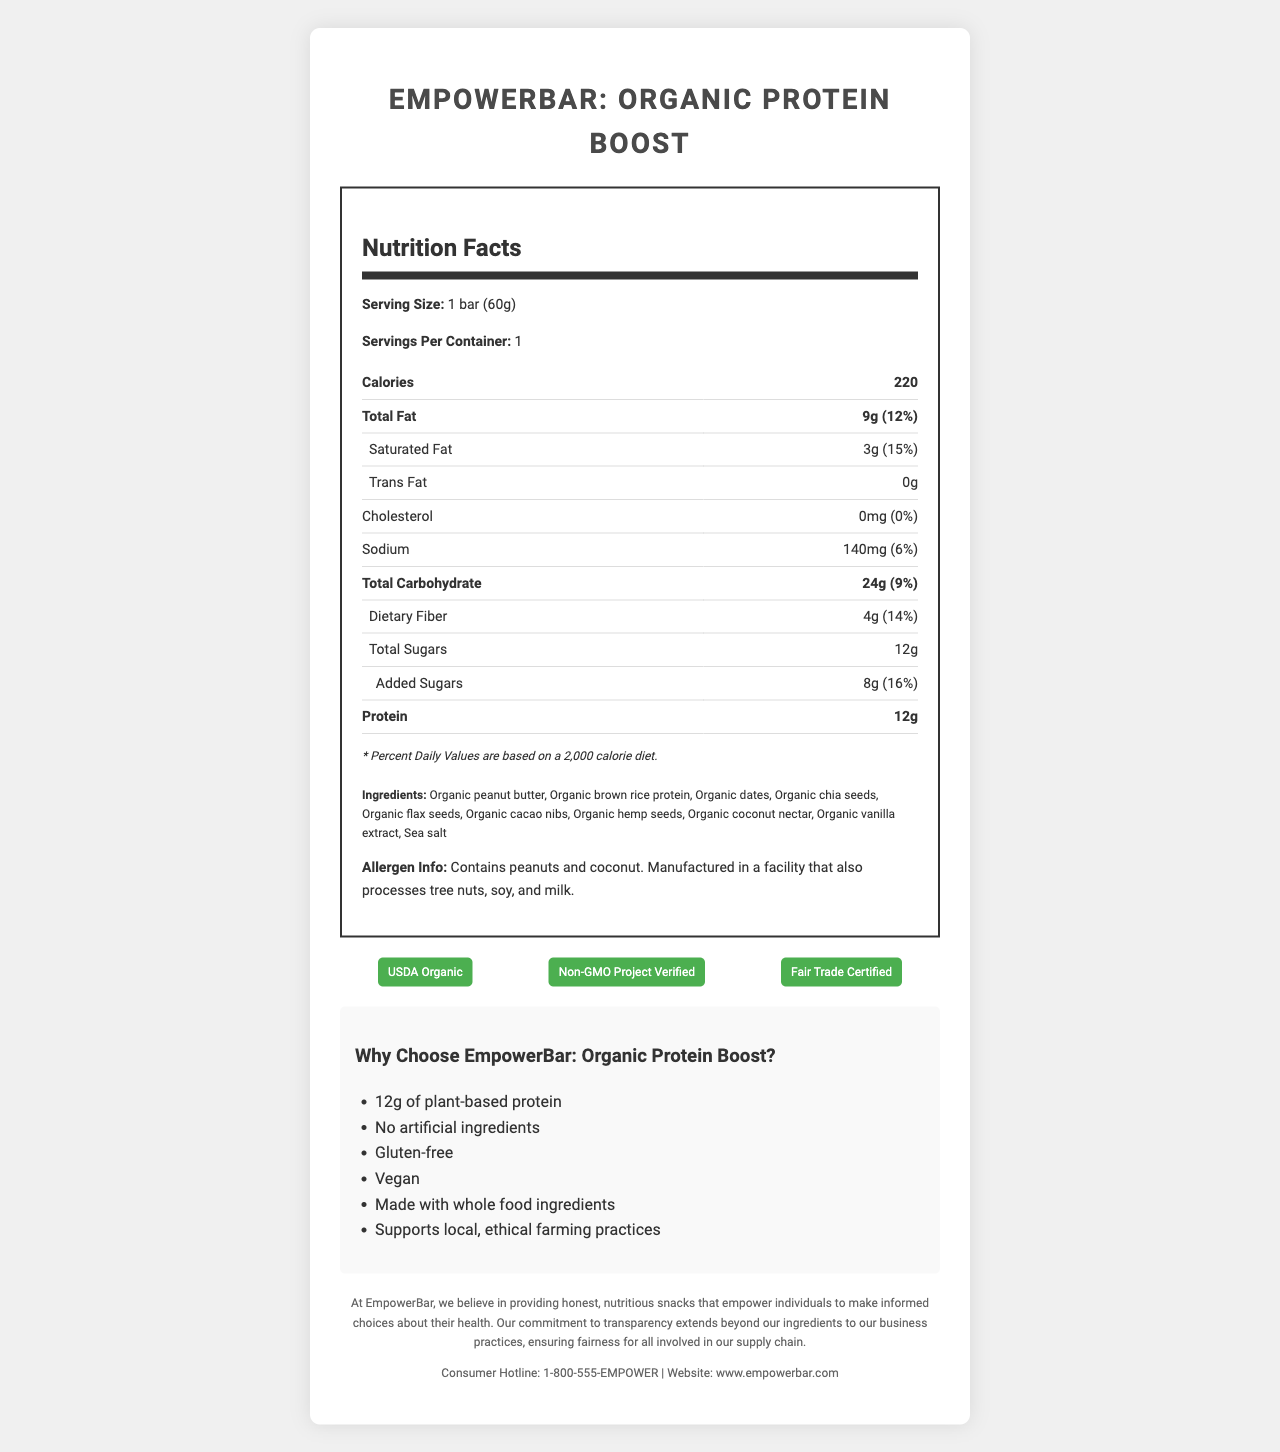what is the serving size? The serving size is clearly stated in the nutrition label section of the document as "1 bar (60g)".
Answer: 1 bar (60g) how many calories does the EmpowerBar contain? According to the nutrition facts, the EmpowerBar contains 220 calories.
Answer: 220 what is the amount of protein per serving? The protein content per serving is listed as 12g in the nutrition label.
Answer: 12g what are the sugars in the EmpowerBar? The document specifies 12g of total sugars, out of which 8g are added sugars.
Answer: 12g total sugars, including 8g added sugars is the EmpowerBar vegan? The marketing claims section lists "Vegan" as one of the features of the product.
Answer: Yes what percentage of the daily value for saturated fat does the EmpowerBar provide? The nutrition facts state that the EmpowerBar provides 15% of the daily value for saturated fat.
Answer: 15% what certifications does the EmpowerBar hold? The certification section clearly lists these three certifications.
Answer: USDA Organic, Non-GMO Project Verified, Fair Trade Certified which ingredient is listed first in the ingredients list? The first ingredient listed is "Organic peanut butter".
Answer: Organic peanut butter does the EmpowerBar contain any allergens? The allergen information specifies that the product contains peanuts and coconut and is manufactured in a facility that also processes tree nuts, soy, and milk.
Answer: Yes, it contains peanuts and coconut. how much iron is in one serving of EmpowerBar? The nutrition facts section shows that one serving contains 1.8mg of iron, which is 10% of the daily value.
Answer: 1.8mg (10% daily value) does the EmpowerBar support local farming practices? One of the marketing claims is that the product supports local, ethical farming practices.
Answer: Yes how many servings are there per container? The document states that there is 1 serving per container.
Answer: 1 what is the total carbohydrate content per serving? According to the nutrition facts, the total carbohydrate content per serving is 24g, which is 9% of the daily value.
Answer: 24g (9% daily value) which of the following is NOT an ingredient in the EmpowerBar: Organic chia seeds, Organic quinoa, Sea salt? A. Organic chia seeds B. Organic quinoa C. Sea salt The ingredients list does not include Organic quinoa, only Organic chia seeds and Sea salt are mentioned.
Answer: B how much dietary fiber is in the EmpowerBar? A. 10g B. 14g C. 4g D. 12g The nutrition facts state that the dietary fiber content is 4g.
Answer: C is there any information on whether the EmpowerBar contains artificial ingredients? There is no specific information in the document about the presence of artificial ingredients.
Answer: No does the nutrition label provide the amount of vitamin C? The nutrition label does not mention the amount of vitamin C.
Answer: No what is the main idea of the document? The document outlines the nutritional facts, ingredients, certifications, allergen information, and marketing claims of a healthy, organic protein bar marketed with emphasis on its natural ingredients and ethical sourcing practices.
Answer: The document provides detailed nutritional information, ingredients, certifications, allergen information, and marketing claims for the EmpowerBar: Organic Protein Boost. how can I contact the company for more information? The company contact information is provided at the end of the document.
Answer: You can call the consumer hotline at 1-800-555-EMPOWER or visit the website www.empowerbar.com 